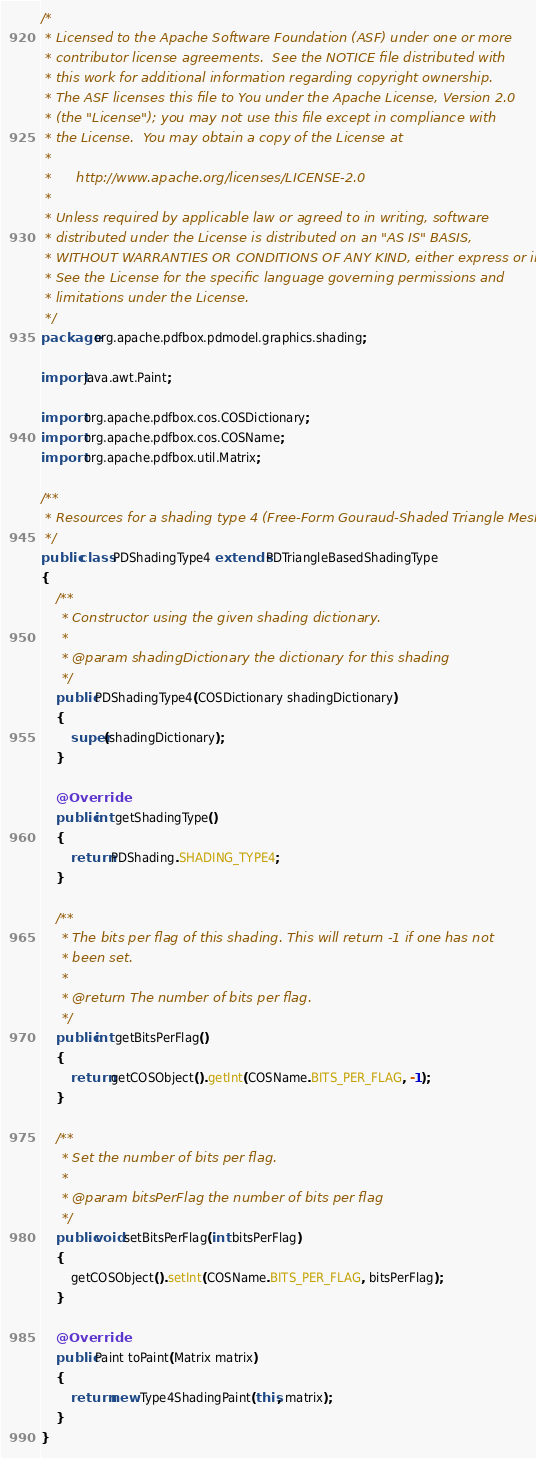<code> <loc_0><loc_0><loc_500><loc_500><_Java_>/*
 * Licensed to the Apache Software Foundation (ASF) under one or more
 * contributor license agreements.  See the NOTICE file distributed with
 * this work for additional information regarding copyright ownership.
 * The ASF licenses this file to You under the Apache License, Version 2.0
 * (the "License"); you may not use this file except in compliance with
 * the License.  You may obtain a copy of the License at
 *
 *      http://www.apache.org/licenses/LICENSE-2.0
 *
 * Unless required by applicable law or agreed to in writing, software
 * distributed under the License is distributed on an "AS IS" BASIS,
 * WITHOUT WARRANTIES OR CONDITIONS OF ANY KIND, either express or implied.
 * See the License for the specific language governing permissions and
 * limitations under the License.
 */
package org.apache.pdfbox.pdmodel.graphics.shading;

import java.awt.Paint;

import org.apache.pdfbox.cos.COSDictionary;
import org.apache.pdfbox.cos.COSName;
import org.apache.pdfbox.util.Matrix;

/**
 * Resources for a shading type 4 (Free-Form Gouraud-Shaded Triangle Mesh).
 */
public class PDShadingType4 extends PDTriangleBasedShadingType
{
    /**
     * Constructor using the given shading dictionary.
     *
     * @param shadingDictionary the dictionary for this shading
     */
    public PDShadingType4(COSDictionary shadingDictionary)
    {
        super(shadingDictionary);
    }

    @Override
    public int getShadingType()
    {
        return PDShading.SHADING_TYPE4;
    }

    /**
     * The bits per flag of this shading. This will return -1 if one has not
     * been set.
     *
     * @return The number of bits per flag.
     */
    public int getBitsPerFlag()
    {
        return getCOSObject().getInt(COSName.BITS_PER_FLAG, -1);
    }

    /**
     * Set the number of bits per flag.
     *
     * @param bitsPerFlag the number of bits per flag
     */
    public void setBitsPerFlag(int bitsPerFlag)
    {
        getCOSObject().setInt(COSName.BITS_PER_FLAG, bitsPerFlag);
    }

    @Override
    public Paint toPaint(Matrix matrix)
    {
        return new Type4ShadingPaint(this, matrix);
    }
}
</code> 